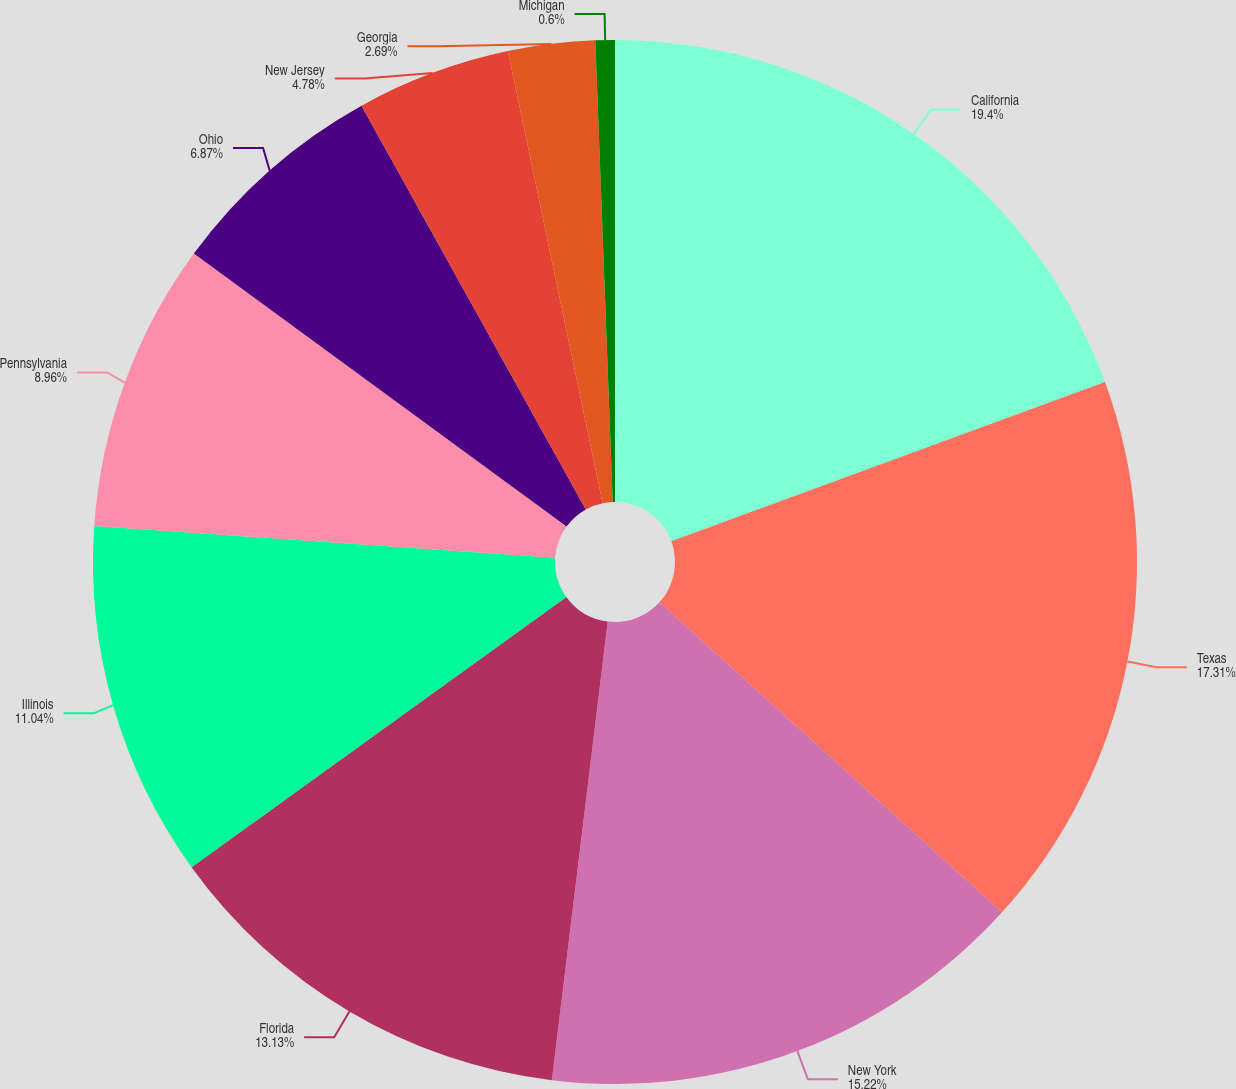<chart> <loc_0><loc_0><loc_500><loc_500><pie_chart><fcel>California<fcel>Texas<fcel>New York<fcel>Florida<fcel>Illinois<fcel>Pennsylvania<fcel>Ohio<fcel>New Jersey<fcel>Georgia<fcel>Michigan<nl><fcel>19.4%<fcel>17.31%<fcel>15.22%<fcel>13.13%<fcel>11.04%<fcel>8.96%<fcel>6.87%<fcel>4.78%<fcel>2.69%<fcel>0.6%<nl></chart> 